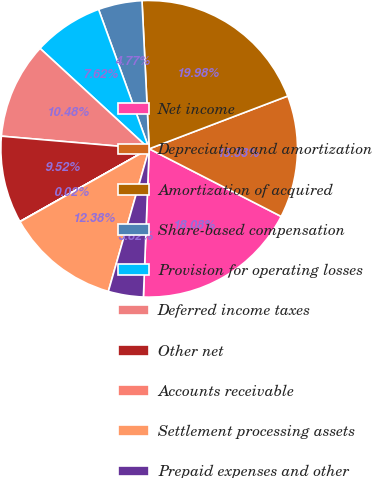Convert chart to OTSL. <chart><loc_0><loc_0><loc_500><loc_500><pie_chart><fcel>Net income<fcel>Depreciation and amortization<fcel>Amortization of acquired<fcel>Share-based compensation<fcel>Provision for operating losses<fcel>Deferred income taxes<fcel>Other net<fcel>Accounts receivable<fcel>Settlement processing assets<fcel>Prepaid expenses and other<nl><fcel>18.08%<fcel>13.33%<fcel>19.98%<fcel>4.77%<fcel>7.62%<fcel>10.48%<fcel>9.52%<fcel>0.02%<fcel>12.38%<fcel>3.82%<nl></chart> 